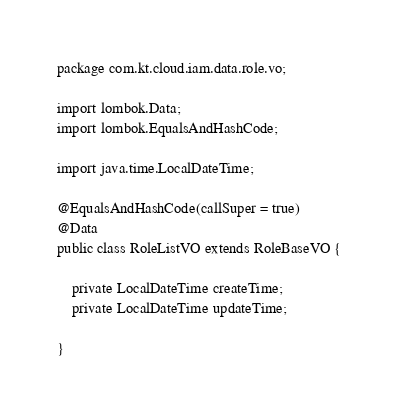<code> <loc_0><loc_0><loc_500><loc_500><_Java_>package com.kt.cloud.iam.data.role.vo;

import lombok.Data;
import lombok.EqualsAndHashCode;

import java.time.LocalDateTime;

@EqualsAndHashCode(callSuper = true)
@Data
public class RoleListVO extends RoleBaseVO {

    private LocalDateTime createTime;
    private LocalDateTime updateTime;

}
</code> 